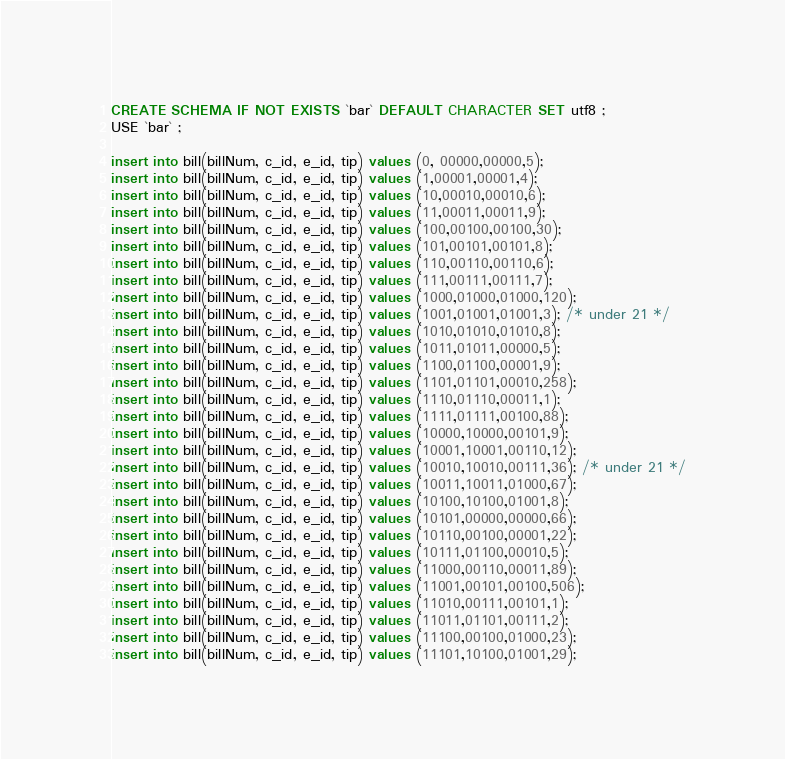Convert code to text. <code><loc_0><loc_0><loc_500><loc_500><_SQL_>CREATE SCHEMA IF NOT EXISTS `bar` DEFAULT CHARACTER SET utf8 ;
USE `bar` ;

insert into bill(billNum, c_id, e_id, tip) values (0, 00000,00000,5);
insert into bill(billNum, c_id, e_id, tip) values (1,00001,00001,4);
insert into bill(billNum, c_id, e_id, tip) values (10,00010,00010,6);
insert into bill(billNum, c_id, e_id, tip) values (11,00011,00011,9);
insert into bill(billNum, c_id, e_id, tip) values (100,00100,00100,30);
insert into bill(billNum, c_id, e_id, tip) values (101,00101,00101,8);
insert into bill(billNum, c_id, e_id, tip) values (110,00110,00110,6);
insert into bill(billNum, c_id, e_id, tip) values (111,00111,00111,7);
insert into bill(billNum, c_id, e_id, tip) values (1000,01000,01000,120);
insert into bill(billNum, c_id, e_id, tip) values (1001,01001,01001,3); /* under 21 */
insert into bill(billNum, c_id, e_id, tip) values (1010,01010,01010,8);
insert into bill(billNum, c_id, e_id, tip) values (1011,01011,00000,5);
insert into bill(billNum, c_id, e_id, tip) values (1100,01100,00001,9);
insert into bill(billNum, c_id, e_id, tip) values (1101,01101,00010,258);
insert into bill(billNum, c_id, e_id, tip) values (1110,01110,00011,1);
insert into bill(billNum, c_id, e_id, tip) values (1111,01111,00100,88);
insert into bill(billNum, c_id, e_id, tip) values (10000,10000,00101,9);
insert into bill(billNum, c_id, e_id, tip) values (10001,10001,00110,12);
insert into bill(billNum, c_id, e_id, tip) values (10010,10010,00111,36); /* under 21 */
insert into bill(billNum, c_id, e_id, tip) values (10011,10011,01000,67);
insert into bill(billNum, c_id, e_id, tip) values (10100,10100,01001,8);
insert into bill(billNum, c_id, e_id, tip) values (10101,00000,00000,66);
insert into bill(billNum, c_id, e_id, tip) values (10110,00100,00001,22);
insert into bill(billNum, c_id, e_id, tip) values (10111,01100,00010,5);
insert into bill(billNum, c_id, e_id, tip) values (11000,00110,00011,89);
insert into bill(billNum, c_id, e_id, tip) values (11001,00101,00100,506);
insert into bill(billNum, c_id, e_id, tip) values (11010,00111,00101,1);
insert into bill(billNum, c_id, e_id, tip) values (11011,01101,00111,2);
insert into bill(billNum, c_id, e_id, tip) values (11100,00100,01000,23);
insert into bill(billNum, c_id, e_id, tip) values (11101,10100,01001,29);
</code> 